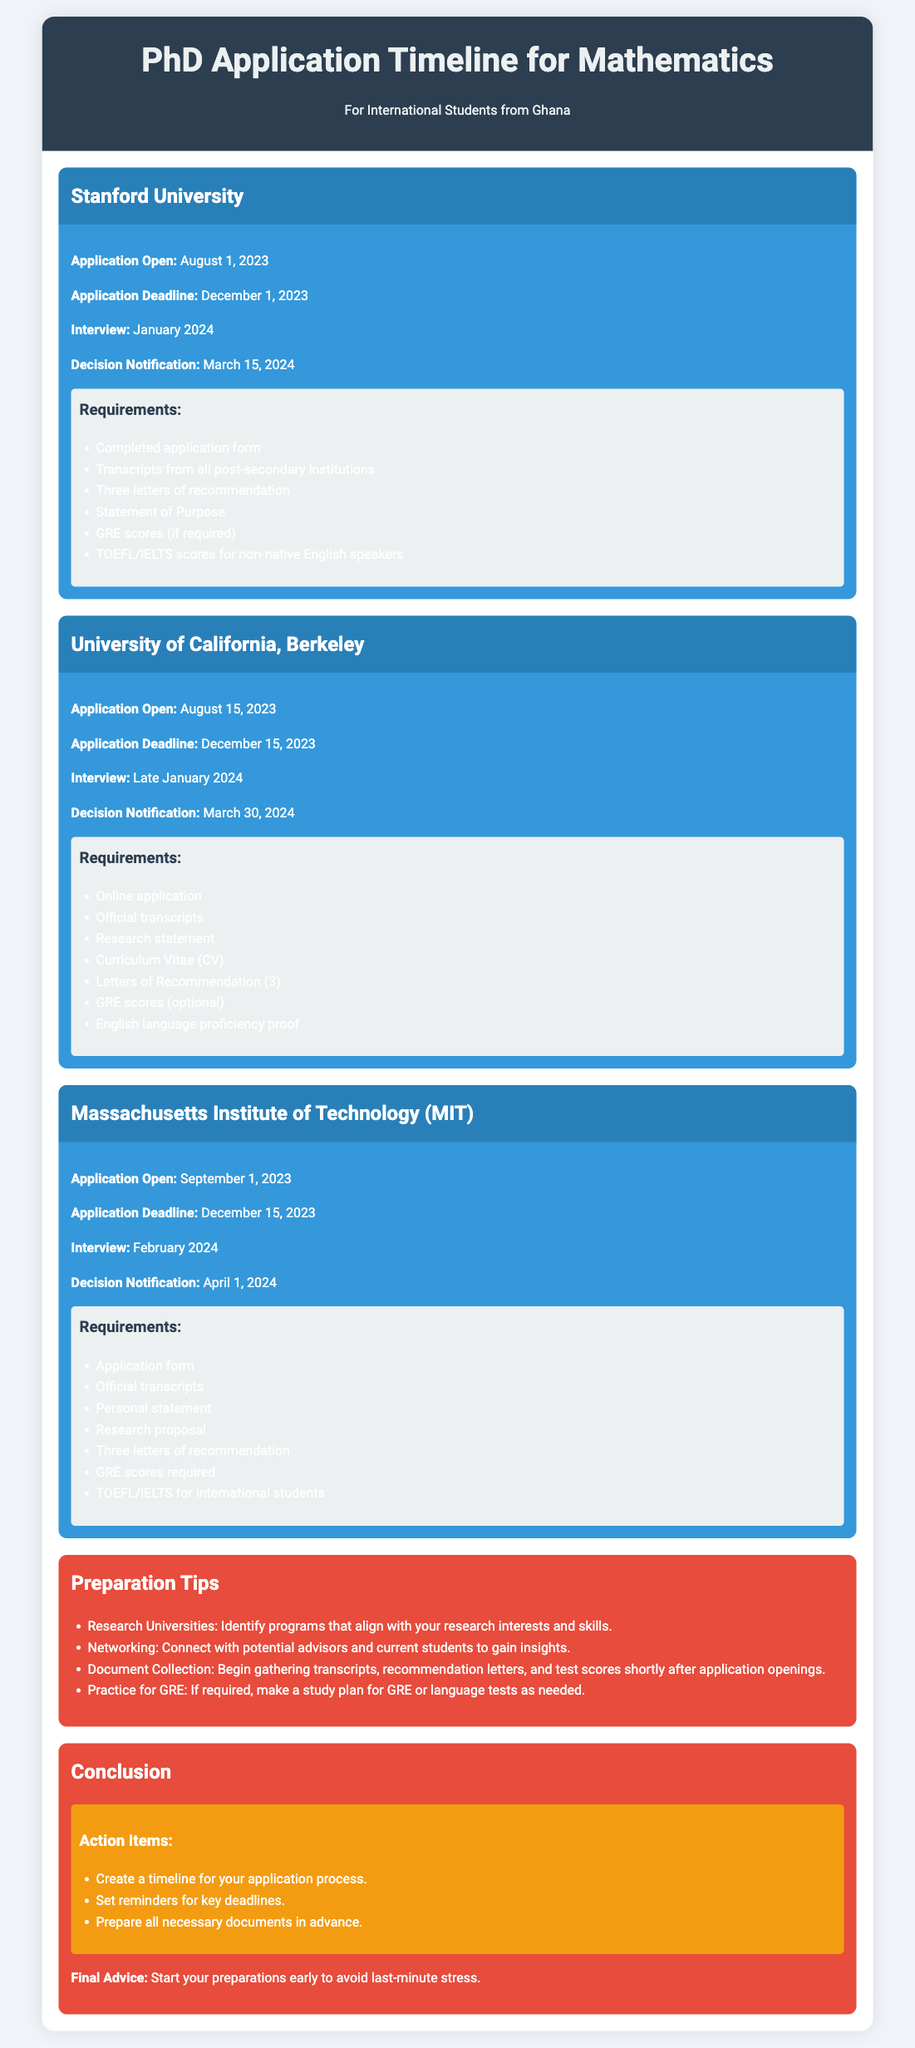What is the application deadline for Stanford University? The application deadline is explicitly stated in the document for Stanford University as December 1, 2023.
Answer: December 1, 2023 When do interviews take place for the University of California, Berkeley? The document specifies that interviews are scheduled for Late January 2024 for this university.
Answer: Late January 2024 What type of statement is required by MIT? The requirements mention a Personal statement as part of the application materials for MIT.
Answer: Personal statement How many letters of recommendation are needed for the Massachusetts Institute of Technology? The document states that three letters of recommendation are required for MIT.
Answer: Three letters of recommendation What is a key preparation tip for international students? The tips emphasize the importance of connecting with potential advisors and current students for insights.
Answer: Networking Which university has an application opening date of September 1, 2023? The application opening date of September 1, 2023 is mentioned for MIT in the document.
Answer: Massachusetts Institute of Technology (MIT) When will decision notifications be sent for Stanford University? The document states that decision notifications for Stanford University will be sent on March 15, 2024.
Answer: March 15, 2024 What is recommended to do early in the application process? The conclusion emphasizes starting preparations early to avoid last-minute stress.
Answer: Start preparations early 